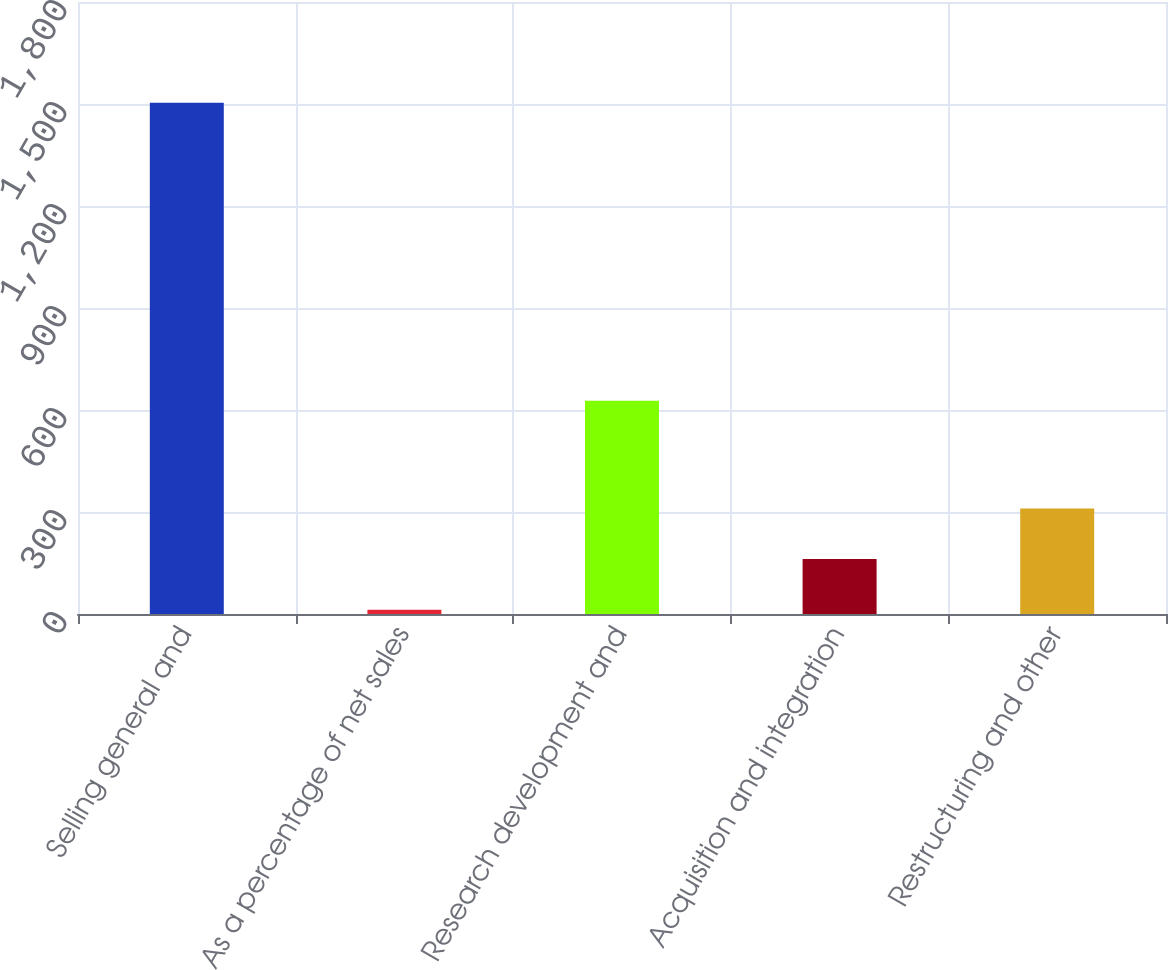Convert chart. <chart><loc_0><loc_0><loc_500><loc_500><bar_chart><fcel>Selling general and<fcel>As a percentage of net sales<fcel>Research development and<fcel>Acquisition and integration<fcel>Restructuring and other<nl><fcel>1504<fcel>12.3<fcel>627<fcel>161.47<fcel>310.64<nl></chart> 